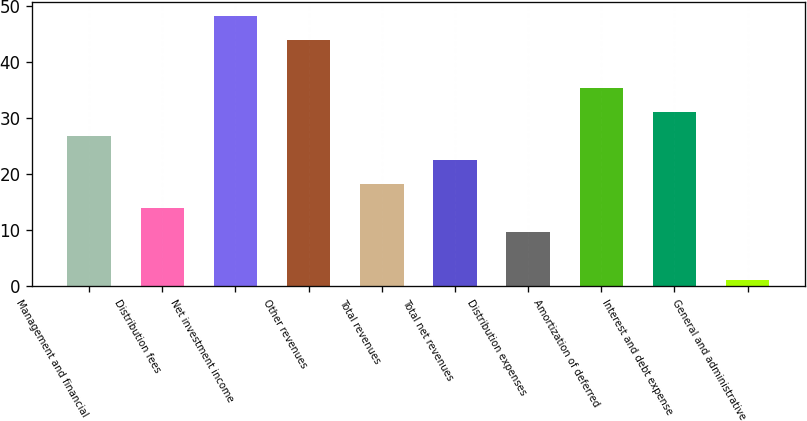<chart> <loc_0><loc_0><loc_500><loc_500><bar_chart><fcel>Management and financial<fcel>Distribution fees<fcel>Net investment income<fcel>Other revenues<fcel>Total revenues<fcel>Total net revenues<fcel>Distribution expenses<fcel>Amortization of deferred<fcel>Interest and debt expense<fcel>General and administrative<nl><fcel>26.8<fcel>13.9<fcel>48.3<fcel>44<fcel>18.2<fcel>22.5<fcel>9.6<fcel>35.4<fcel>31.1<fcel>1<nl></chart> 